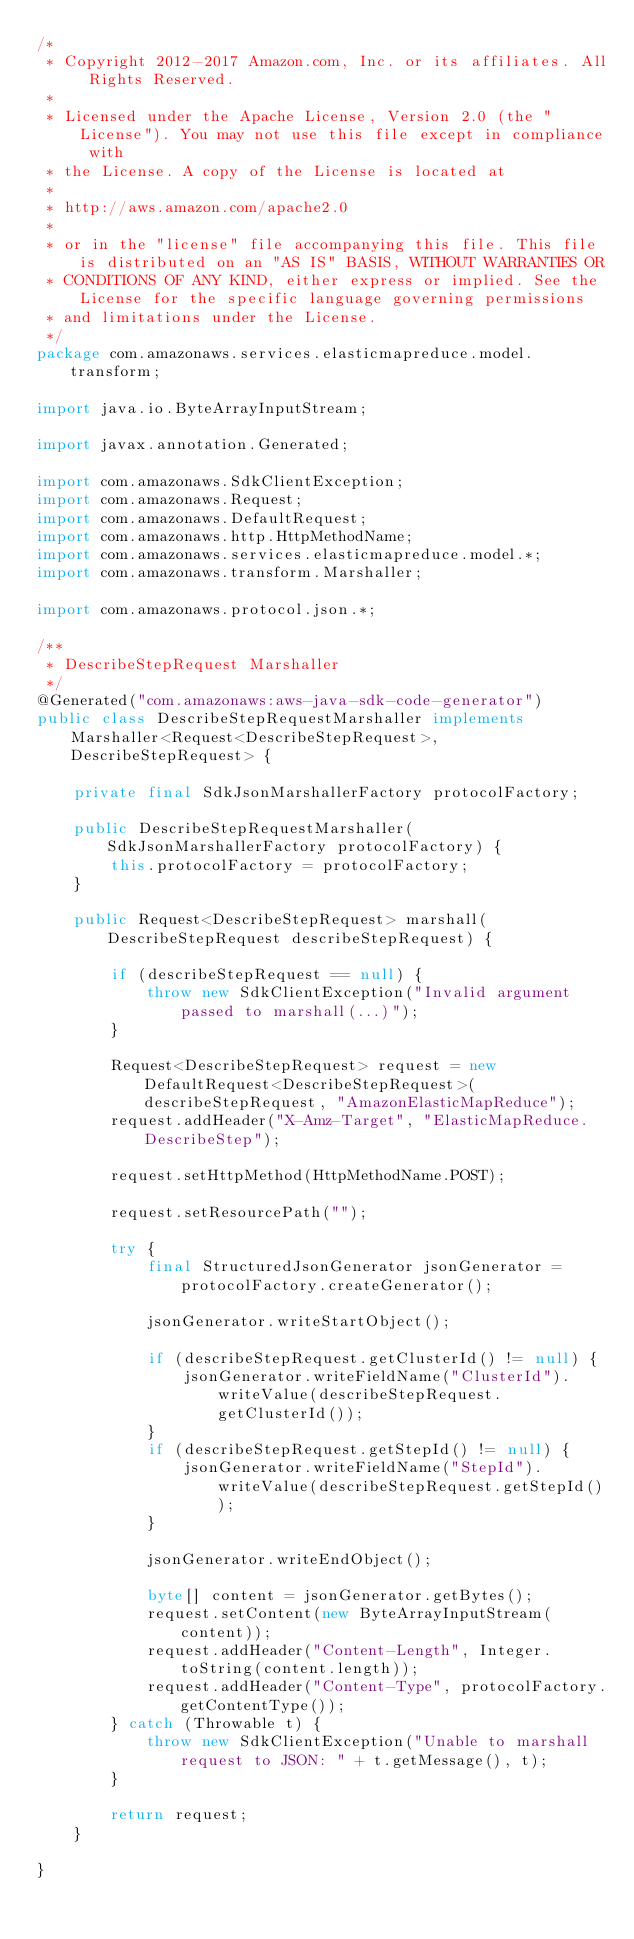Convert code to text. <code><loc_0><loc_0><loc_500><loc_500><_Java_>/*
 * Copyright 2012-2017 Amazon.com, Inc. or its affiliates. All Rights Reserved.
 * 
 * Licensed under the Apache License, Version 2.0 (the "License"). You may not use this file except in compliance with
 * the License. A copy of the License is located at
 * 
 * http://aws.amazon.com/apache2.0
 * 
 * or in the "license" file accompanying this file. This file is distributed on an "AS IS" BASIS, WITHOUT WARRANTIES OR
 * CONDITIONS OF ANY KIND, either express or implied. See the License for the specific language governing permissions
 * and limitations under the License.
 */
package com.amazonaws.services.elasticmapreduce.model.transform;

import java.io.ByteArrayInputStream;

import javax.annotation.Generated;

import com.amazonaws.SdkClientException;
import com.amazonaws.Request;
import com.amazonaws.DefaultRequest;
import com.amazonaws.http.HttpMethodName;
import com.amazonaws.services.elasticmapreduce.model.*;
import com.amazonaws.transform.Marshaller;

import com.amazonaws.protocol.json.*;

/**
 * DescribeStepRequest Marshaller
 */
@Generated("com.amazonaws:aws-java-sdk-code-generator")
public class DescribeStepRequestMarshaller implements Marshaller<Request<DescribeStepRequest>, DescribeStepRequest> {

    private final SdkJsonMarshallerFactory protocolFactory;

    public DescribeStepRequestMarshaller(SdkJsonMarshallerFactory protocolFactory) {
        this.protocolFactory = protocolFactory;
    }

    public Request<DescribeStepRequest> marshall(DescribeStepRequest describeStepRequest) {

        if (describeStepRequest == null) {
            throw new SdkClientException("Invalid argument passed to marshall(...)");
        }

        Request<DescribeStepRequest> request = new DefaultRequest<DescribeStepRequest>(describeStepRequest, "AmazonElasticMapReduce");
        request.addHeader("X-Amz-Target", "ElasticMapReduce.DescribeStep");

        request.setHttpMethod(HttpMethodName.POST);

        request.setResourcePath("");

        try {
            final StructuredJsonGenerator jsonGenerator = protocolFactory.createGenerator();

            jsonGenerator.writeStartObject();

            if (describeStepRequest.getClusterId() != null) {
                jsonGenerator.writeFieldName("ClusterId").writeValue(describeStepRequest.getClusterId());
            }
            if (describeStepRequest.getStepId() != null) {
                jsonGenerator.writeFieldName("StepId").writeValue(describeStepRequest.getStepId());
            }

            jsonGenerator.writeEndObject();

            byte[] content = jsonGenerator.getBytes();
            request.setContent(new ByteArrayInputStream(content));
            request.addHeader("Content-Length", Integer.toString(content.length));
            request.addHeader("Content-Type", protocolFactory.getContentType());
        } catch (Throwable t) {
            throw new SdkClientException("Unable to marshall request to JSON: " + t.getMessage(), t);
        }

        return request;
    }

}
</code> 